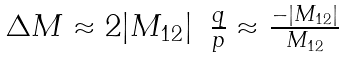Convert formula to latex. <formula><loc_0><loc_0><loc_500><loc_500>\begin{array} { l c r } { { \Delta M \approx 2 | M _ { 1 2 } | } } & { { \frac { q } { p } \approx \frac { - | M _ { 1 2 } | } { M _ { 1 2 } } } } \end{array}</formula> 